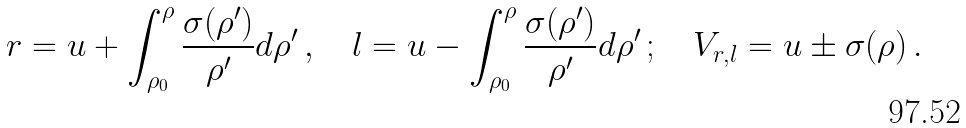Convert formula to latex. <formula><loc_0><loc_0><loc_500><loc_500>r = u + \int ^ { \rho } _ { \rho _ { 0 } } \frac { \sigma ( \rho ^ { \prime } ) } { \rho ^ { \prime } } d \rho ^ { \prime } \, , \quad l = u - \int ^ { \rho } _ { \rho _ { 0 } } \frac { \sigma ( \rho ^ { \prime } ) } { \rho ^ { \prime } } d \rho ^ { \prime } \, ; \quad V _ { r , l } = u \pm \sigma ( \rho ) \, .</formula> 